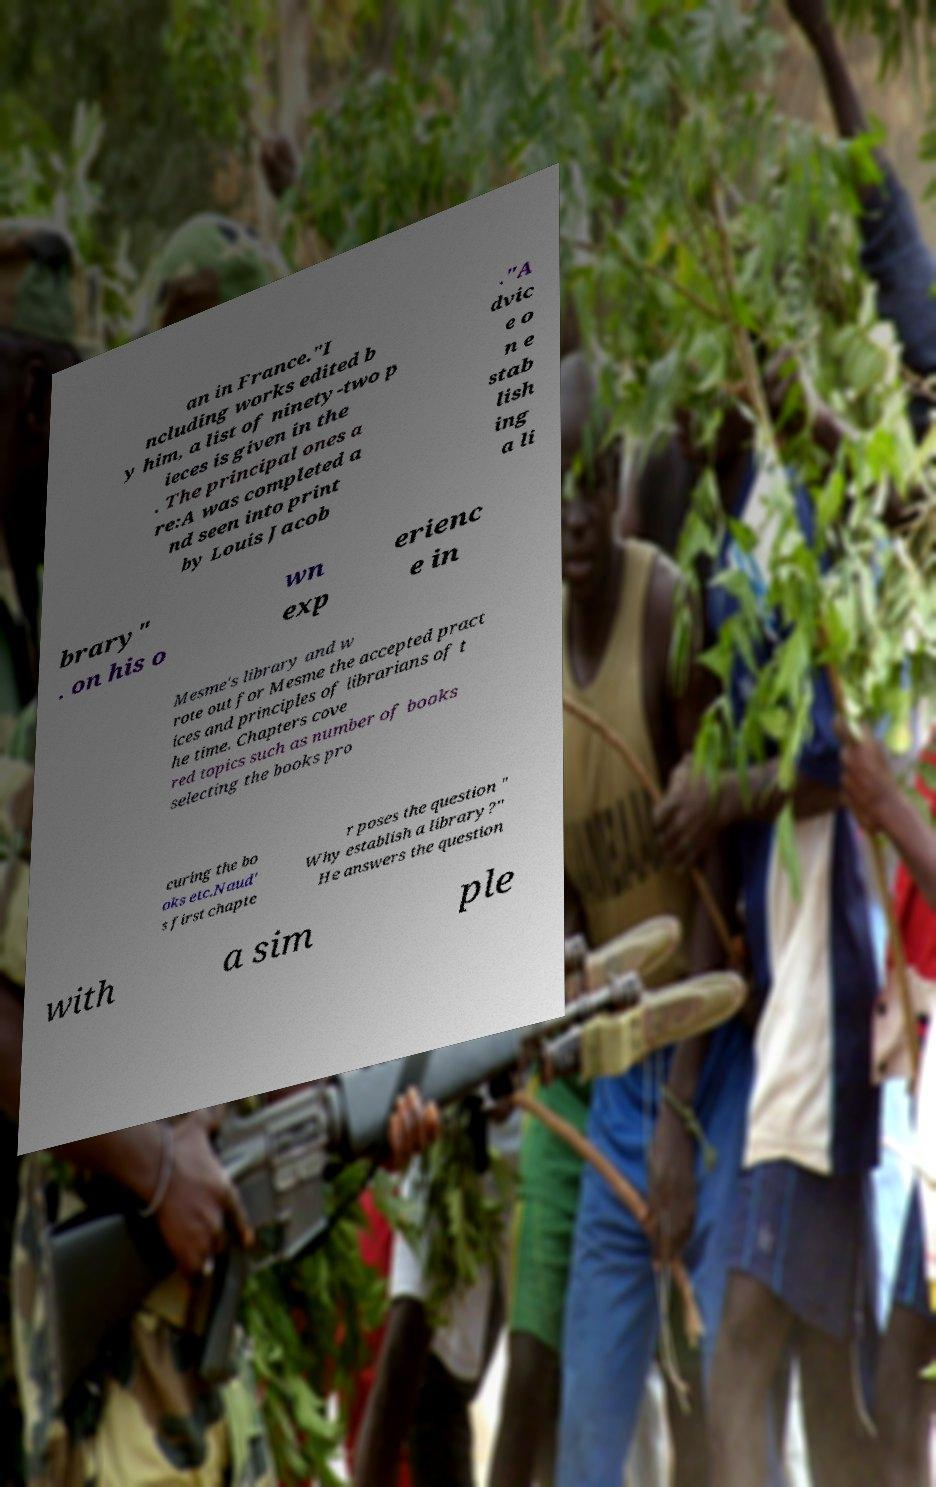I need the written content from this picture converted into text. Can you do that? an in France."I ncluding works edited b y him, a list of ninety-two p ieces is given in the . The principal ones a re:A was completed a nd seen into print by Louis Jacob ."A dvic e o n e stab lish ing a li brary" . on his o wn exp erienc e in Mesme's library and w rote out for Mesme the accepted pract ices and principles of librarians of t he time. Chapters cove red topics such as number of books selecting the books pro curing the bo oks etc.Naud' s first chapte r poses the question " Why establish a library?" He answers the question with a sim ple 